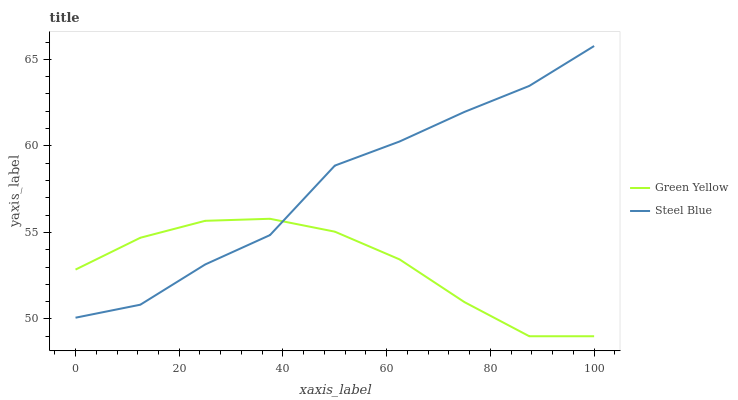Does Green Yellow have the minimum area under the curve?
Answer yes or no. Yes. Does Steel Blue have the maximum area under the curve?
Answer yes or no. Yes. Does Steel Blue have the minimum area under the curve?
Answer yes or no. No. Is Green Yellow the smoothest?
Answer yes or no. Yes. Is Steel Blue the roughest?
Answer yes or no. Yes. Is Steel Blue the smoothest?
Answer yes or no. No. Does Green Yellow have the lowest value?
Answer yes or no. Yes. Does Steel Blue have the lowest value?
Answer yes or no. No. Does Steel Blue have the highest value?
Answer yes or no. Yes. Does Green Yellow intersect Steel Blue?
Answer yes or no. Yes. Is Green Yellow less than Steel Blue?
Answer yes or no. No. Is Green Yellow greater than Steel Blue?
Answer yes or no. No. 